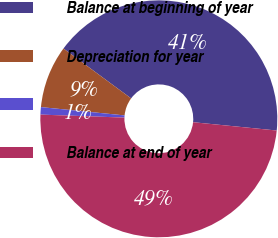Convert chart. <chart><loc_0><loc_0><loc_500><loc_500><pie_chart><fcel>Balance at beginning of year<fcel>Depreciation for year<fcel>Unnamed: 2<fcel>Balance at end of year<nl><fcel>41.47%<fcel>8.53%<fcel>1.01%<fcel>48.99%<nl></chart> 